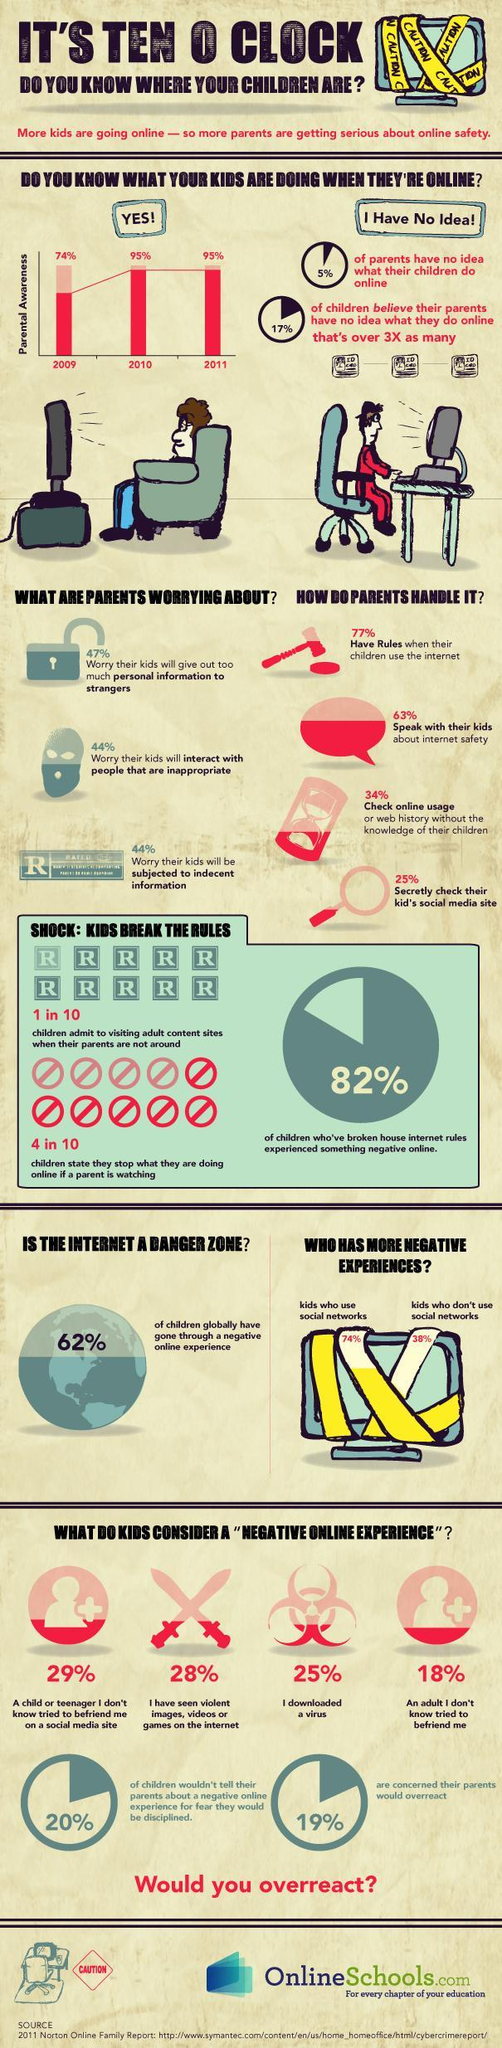What percentage of parents didn't speak with their kids about internet safety?
Answer the question with a short phrase. 37% Who has more negative experience-kids who didn't use social media, kids who use social media? kids who use social media Which all year's percentage of parental awareness about kids is the same? 2010, 2011 What percentage of parents check online usage with knowledge of their children? 66% What percentage of children globally have not gone through a negative online experience? 38% What percentage of parents have an idea of what their children do online? 95% What percentage of kids didn't consider downloading a virus as a negative online experience? 75% What percentage of kids didn't consider to have seen violent images, videos, or games on the internet as a negative online experience? 72% 